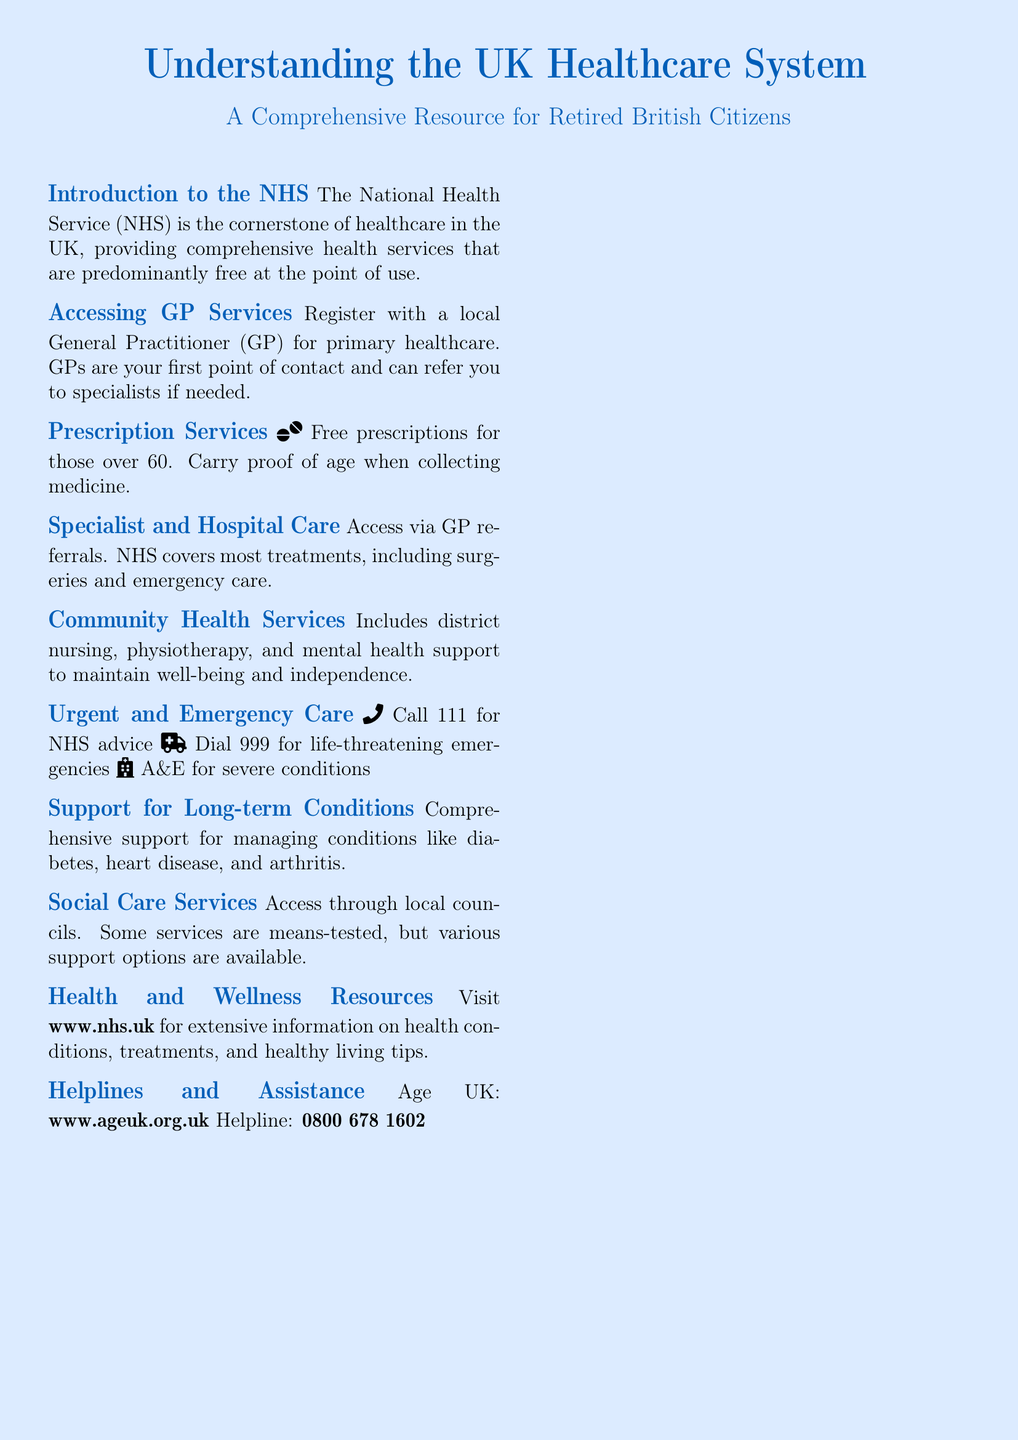What is the cornerstone of healthcare in the UK? The document states that the National Health Service (NHS) is the cornerstone of healthcare in the UK.
Answer: NHS What age qualifies for free prescriptions? The document mentions that free prescriptions are available for those over a certain age.
Answer: 60 What is the first point of contact in the healthcare system? The document specifies that GPs are the first point of contact for primary healthcare.
Answer: GPs Which helpline number should you call for NHS advice? The document provides a specific number to call for NHS advice.
Answer: 111 What services are accessed through local councils? The document describes social care services as accessible through local councils.
Answer: Social care services How can you manage long-term conditions according to the document? The document notes that there is comprehensive support available for managing certain chronic conditions.
Answer: Support for long-term conditions Where can you find information on health conditions? The document suggests a website for extensive information about health conditions and treatments.
Answer: www.nhs.uk What should you do in life-threatening emergencies? The document indicates an action to take during life-threatening emergencies.
Answer: Dial 999 